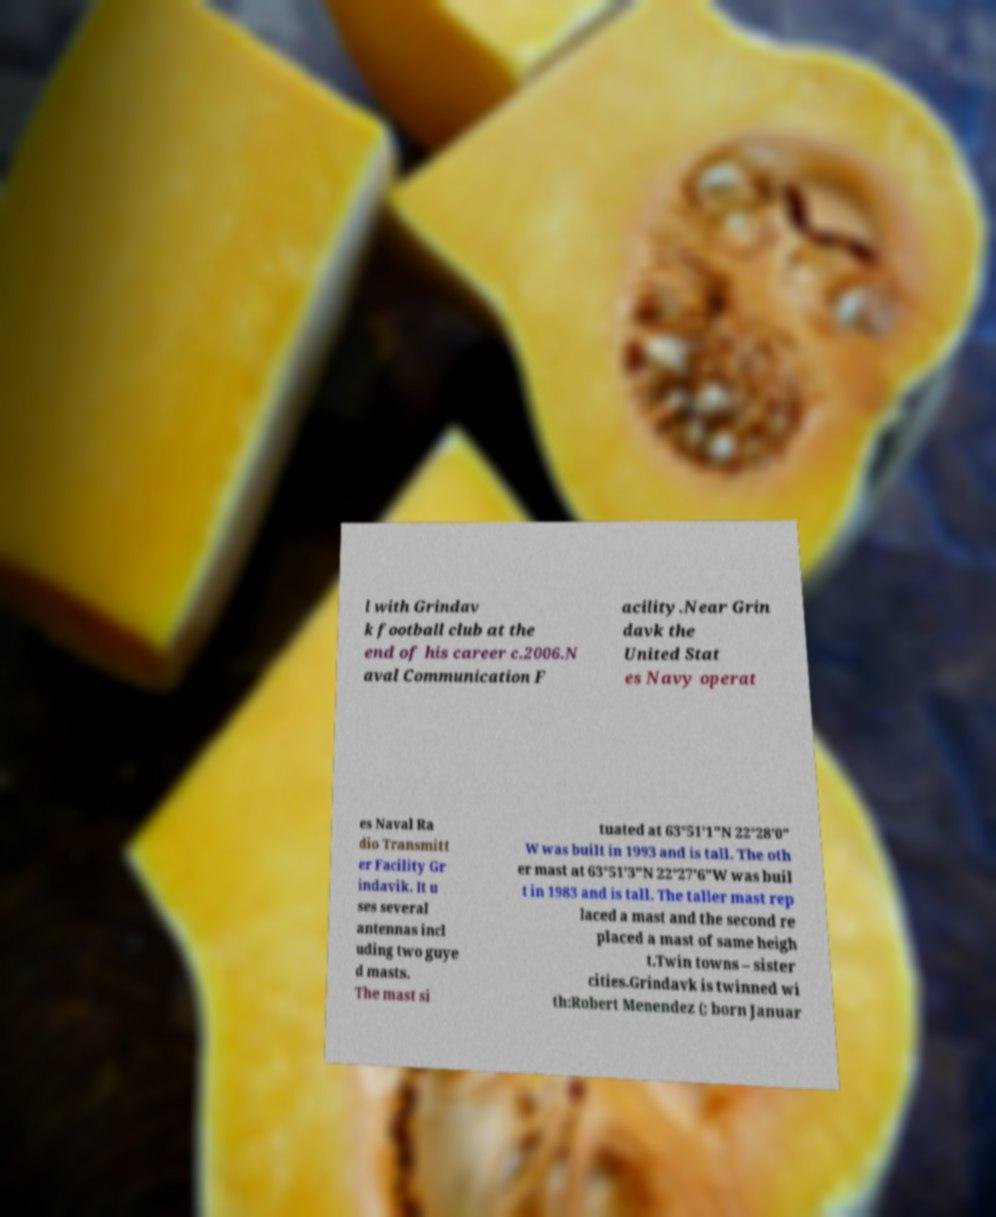Could you assist in decoding the text presented in this image and type it out clearly? l with Grindav k football club at the end of his career c.2006.N aval Communication F acility.Near Grin davk the United Stat es Navy operat es Naval Ra dio Transmitt er Facility Gr indavik. It u ses several antennas incl uding two guye d masts. The mast si tuated at 63°51′1″N 22°28′0″ W was built in 1993 and is tall. The oth er mast at 63°51′3″N 22°27′6″W was buil t in 1983 and is tall. The taller mast rep laced a mast and the second re placed a mast of same heigh t.Twin towns – sister cities.Grindavk is twinned wi th:Robert Menendez (; born Januar 